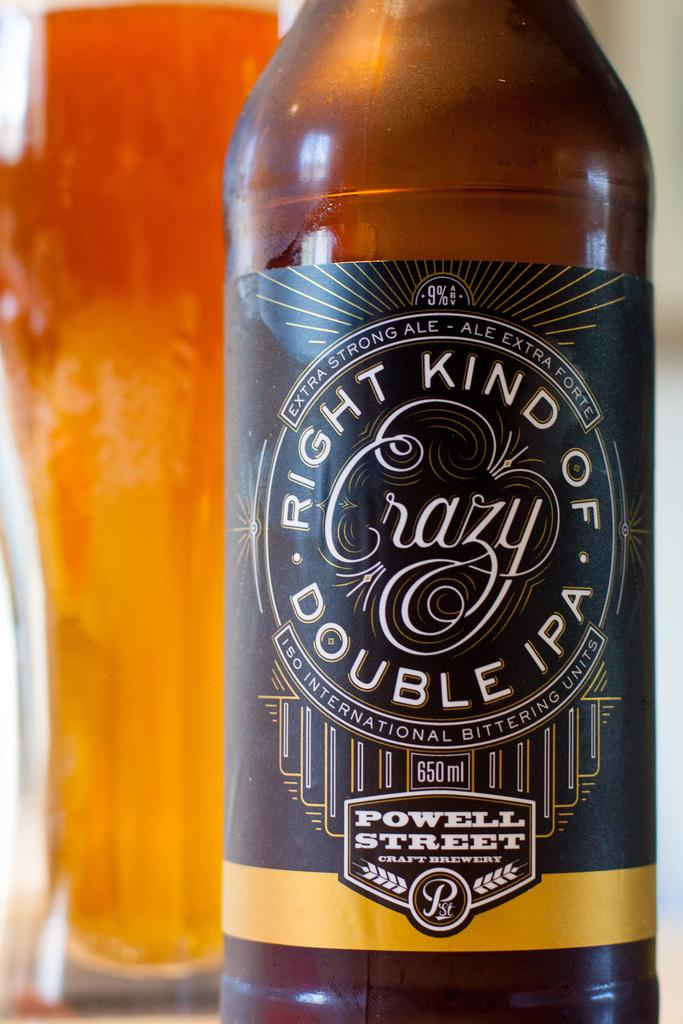<image>
Provide a brief description of the given image. A bottle of ale from Powell Street brewery sits in front of a full beer glass. 